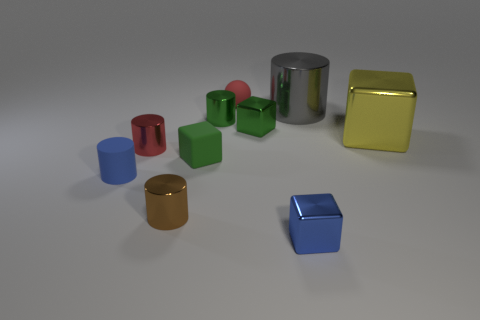Is there any other thing that has the same shape as the red matte thing?
Keep it short and to the point. No. There is a tiny shiny cube that is behind the tiny red metal cylinder; is it the same color as the rubber block?
Give a very brief answer. Yes. There is a metallic cube that is behind the blue rubber object and left of the big cylinder; what color is it?
Make the answer very short. Green. How many green objects are the same size as the matte cylinder?
Keep it short and to the point. 3. What size is the block that is both in front of the yellow metal object and on the right side of the red rubber ball?
Offer a terse response. Small. There is a small shiny cube that is behind the large metallic thing in front of the gray object; what number of brown metallic things are left of it?
Offer a terse response. 1. Are there any tiny objects of the same color as the small rubber cylinder?
Your answer should be compact. Yes. The matte ball that is the same size as the blue cylinder is what color?
Offer a very short reply. Red. There is a tiny matte thing behind the red object to the left of the small rubber object behind the small green rubber object; what is its shape?
Keep it short and to the point. Sphere. What number of tiny blue objects are left of the small rubber object behind the large gray cylinder?
Provide a succinct answer. 1. 